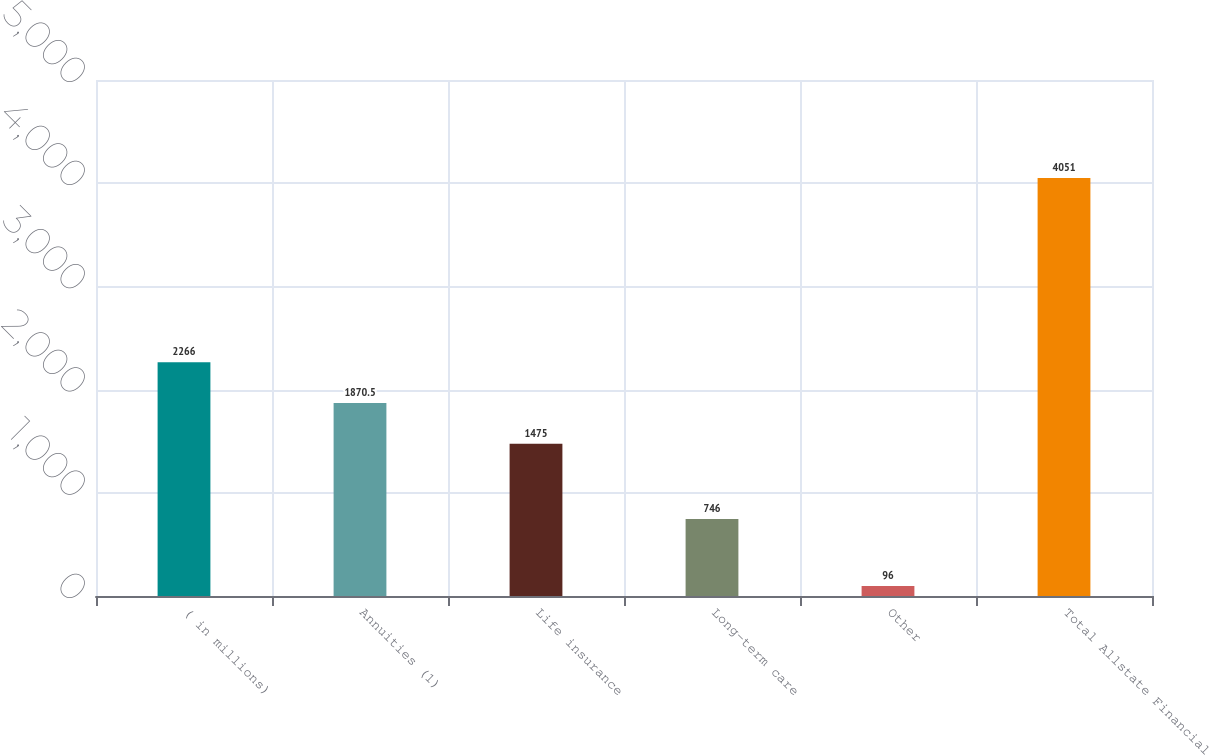<chart> <loc_0><loc_0><loc_500><loc_500><bar_chart><fcel>( in millions)<fcel>Annuities (1)<fcel>Life insurance<fcel>Long-term care<fcel>Other<fcel>Total Allstate Financial<nl><fcel>2266<fcel>1870.5<fcel>1475<fcel>746<fcel>96<fcel>4051<nl></chart> 